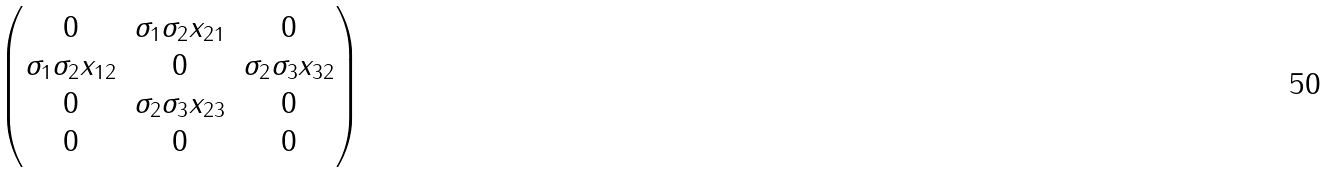<formula> <loc_0><loc_0><loc_500><loc_500>\begin{pmatrix} 0 & \sigma _ { 1 } \sigma _ { 2 } x _ { 2 1 } & 0 \\ \sigma _ { 1 } \sigma _ { 2 } x _ { 1 2 } & 0 & \sigma _ { 2 } \sigma _ { 3 } x _ { 3 2 } \\ 0 & \sigma _ { 2 } \sigma _ { 3 } x _ { 2 3 } & 0 \\ 0 & 0 & 0 \end{pmatrix}</formula> 